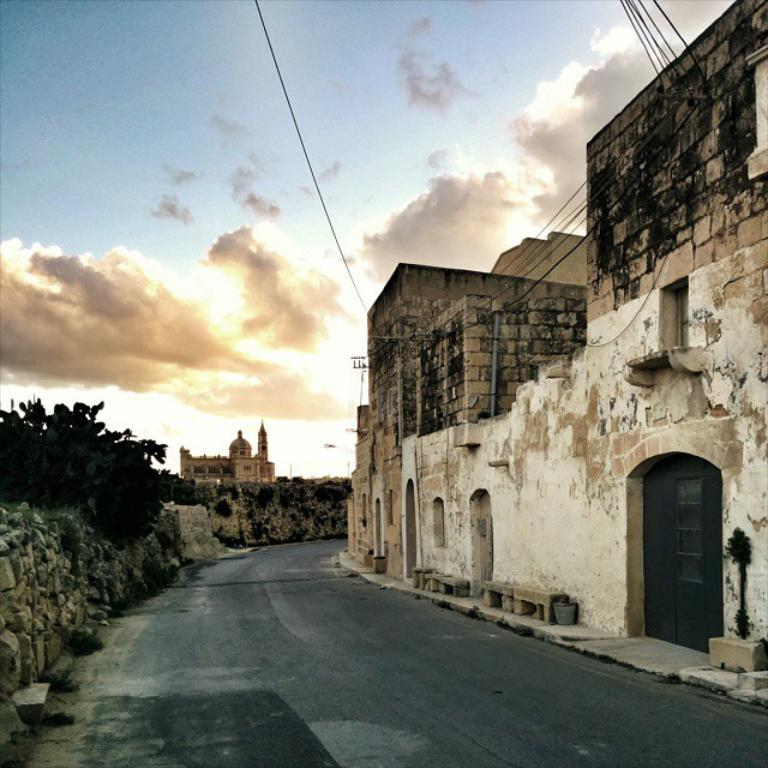What type of structures are located on the right side of the image? There are houses on the right side of the image. What can be seen running through the image? Cables are present in the image. What type of vegetation is on the left side of the image? There are trees on the left side of the image. What other man-made structures are present on the left side of the image? There is a building and a wall in the left side of the image. What is visible at the top of the image? The sky is visible in the image, and clouds are present in the sky. What is at the bottom of the image? There is a road at the bottom of the image. What type of boat is sailing on the road in the image? There is no boat present in the image, and the road is not a body of water for a boat to sail on. What songs are being sung by the clouds in the image? The clouds in the image are not singing songs; they are simply part of the sky's natural appearance. 